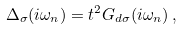<formula> <loc_0><loc_0><loc_500><loc_500>\Delta _ { \sigma } ( i \omega _ { n } ) = t ^ { 2 } G _ { d \sigma } ( i \omega _ { n } ) \, ,</formula> 